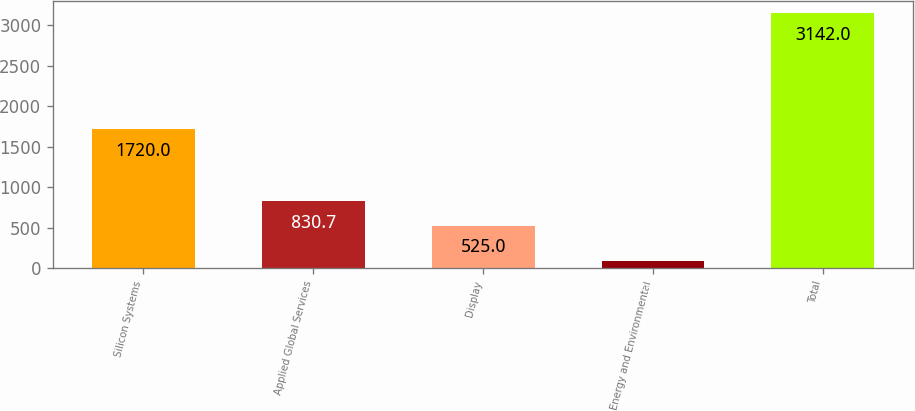Convert chart. <chart><loc_0><loc_0><loc_500><loc_500><bar_chart><fcel>Silicon Systems<fcel>Applied Global Services<fcel>Display<fcel>Energy and Environmental<fcel>Total<nl><fcel>1720<fcel>830.7<fcel>525<fcel>85<fcel>3142<nl></chart> 